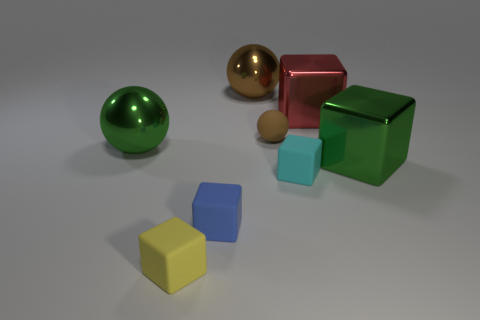Subtract all cyan cubes. How many cubes are left? 4 Subtract all green spheres. How many spheres are left? 2 Add 1 large gray things. How many objects exist? 9 Subtract all balls. How many objects are left? 5 Subtract 2 blocks. How many blocks are left? 3 Subtract all yellow cubes. Subtract all purple cylinders. How many cubes are left? 4 Subtract all purple balls. How many purple blocks are left? 0 Subtract all tiny gray matte cubes. Subtract all big brown shiny balls. How many objects are left? 7 Add 3 tiny blue blocks. How many tiny blue blocks are left? 4 Add 5 tiny brown spheres. How many tiny brown spheres exist? 6 